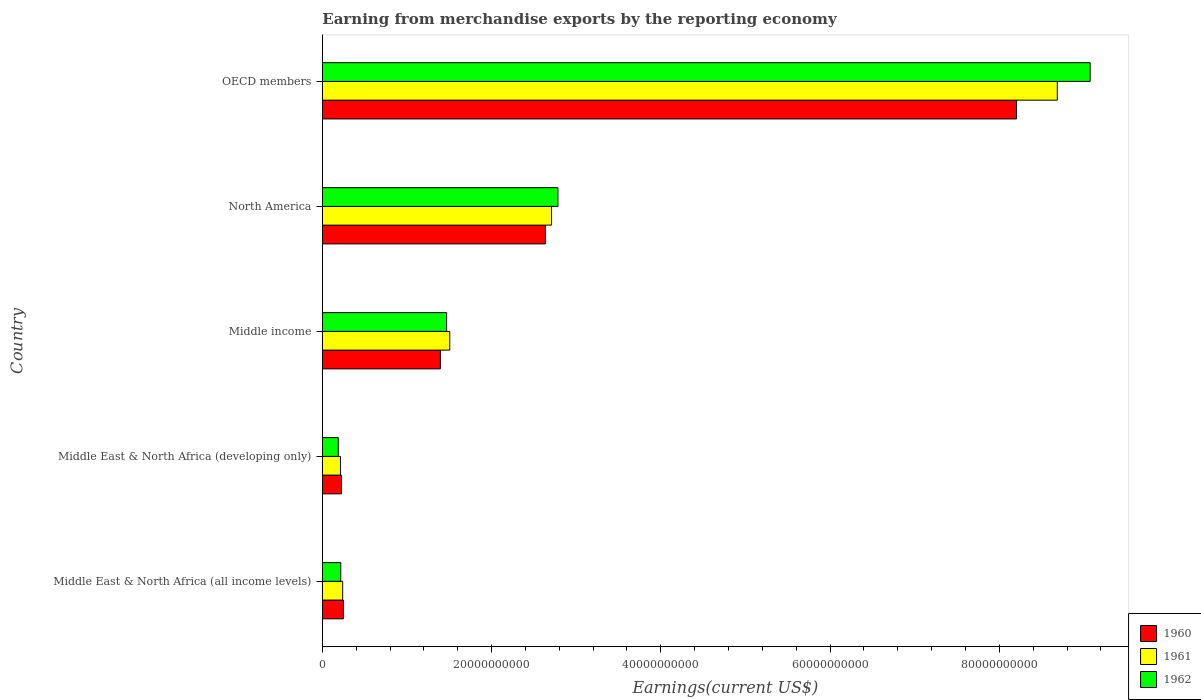Are the number of bars per tick equal to the number of legend labels?
Your response must be concise. Yes. Are the number of bars on each tick of the Y-axis equal?
Your answer should be compact. Yes. How many bars are there on the 4th tick from the bottom?
Ensure brevity in your answer.  3. What is the label of the 2nd group of bars from the top?
Provide a succinct answer. North America. What is the amount earned from merchandise exports in 1960 in OECD members?
Offer a terse response. 8.20e+1. Across all countries, what is the maximum amount earned from merchandise exports in 1960?
Ensure brevity in your answer.  8.20e+1. Across all countries, what is the minimum amount earned from merchandise exports in 1961?
Your answer should be compact. 2.15e+09. In which country was the amount earned from merchandise exports in 1960 maximum?
Make the answer very short. OECD members. In which country was the amount earned from merchandise exports in 1961 minimum?
Give a very brief answer. Middle East & North Africa (developing only). What is the total amount earned from merchandise exports in 1961 in the graph?
Your answer should be compact. 1.34e+11. What is the difference between the amount earned from merchandise exports in 1961 in North America and that in OECD members?
Give a very brief answer. -5.98e+1. What is the difference between the amount earned from merchandise exports in 1962 in Middle East & North Africa (developing only) and the amount earned from merchandise exports in 1960 in OECD members?
Your answer should be very brief. -8.01e+1. What is the average amount earned from merchandise exports in 1961 per country?
Your answer should be very brief. 2.67e+1. What is the difference between the amount earned from merchandise exports in 1960 and amount earned from merchandise exports in 1961 in Middle East & North Africa (developing only)?
Your answer should be compact. 1.18e+08. What is the ratio of the amount earned from merchandise exports in 1962 in Middle East & North Africa (developing only) to that in Middle income?
Keep it short and to the point. 0.13. What is the difference between the highest and the second highest amount earned from merchandise exports in 1960?
Give a very brief answer. 5.57e+1. What is the difference between the highest and the lowest amount earned from merchandise exports in 1961?
Give a very brief answer. 8.47e+1. In how many countries, is the amount earned from merchandise exports in 1960 greater than the average amount earned from merchandise exports in 1960 taken over all countries?
Provide a succinct answer. 2. Is the sum of the amount earned from merchandise exports in 1961 in Middle income and OECD members greater than the maximum amount earned from merchandise exports in 1962 across all countries?
Your response must be concise. Yes. What does the 1st bar from the top in North America represents?
Offer a terse response. 1962. What does the 2nd bar from the bottom in North America represents?
Offer a very short reply. 1961. Is it the case that in every country, the sum of the amount earned from merchandise exports in 1961 and amount earned from merchandise exports in 1962 is greater than the amount earned from merchandise exports in 1960?
Give a very brief answer. Yes. How many bars are there?
Give a very brief answer. 15. Are all the bars in the graph horizontal?
Offer a very short reply. Yes. How many countries are there in the graph?
Your response must be concise. 5. Does the graph contain any zero values?
Offer a very short reply. No. How many legend labels are there?
Offer a terse response. 3. How are the legend labels stacked?
Provide a short and direct response. Vertical. What is the title of the graph?
Provide a short and direct response. Earning from merchandise exports by the reporting economy. Does "1984" appear as one of the legend labels in the graph?
Your answer should be very brief. No. What is the label or title of the X-axis?
Make the answer very short. Earnings(current US$). What is the label or title of the Y-axis?
Make the answer very short. Country. What is the Earnings(current US$) of 1960 in Middle East & North Africa (all income levels)?
Your answer should be compact. 2.49e+09. What is the Earnings(current US$) in 1961 in Middle East & North Africa (all income levels)?
Keep it short and to the point. 2.40e+09. What is the Earnings(current US$) of 1962 in Middle East & North Africa (all income levels)?
Keep it short and to the point. 2.18e+09. What is the Earnings(current US$) of 1960 in Middle East & North Africa (developing only)?
Offer a terse response. 2.26e+09. What is the Earnings(current US$) in 1961 in Middle East & North Africa (developing only)?
Your answer should be compact. 2.15e+09. What is the Earnings(current US$) of 1962 in Middle East & North Africa (developing only)?
Make the answer very short. 1.89e+09. What is the Earnings(current US$) in 1960 in Middle income?
Ensure brevity in your answer.  1.39e+1. What is the Earnings(current US$) of 1961 in Middle income?
Your response must be concise. 1.51e+1. What is the Earnings(current US$) of 1962 in Middle income?
Your answer should be very brief. 1.47e+1. What is the Earnings(current US$) in 1960 in North America?
Provide a short and direct response. 2.64e+1. What is the Earnings(current US$) of 1961 in North America?
Ensure brevity in your answer.  2.71e+1. What is the Earnings(current US$) of 1962 in North America?
Offer a terse response. 2.78e+1. What is the Earnings(current US$) in 1960 in OECD members?
Make the answer very short. 8.20e+1. What is the Earnings(current US$) of 1961 in OECD members?
Make the answer very short. 8.68e+1. What is the Earnings(current US$) in 1962 in OECD members?
Make the answer very short. 9.07e+1. Across all countries, what is the maximum Earnings(current US$) of 1960?
Provide a short and direct response. 8.20e+1. Across all countries, what is the maximum Earnings(current US$) in 1961?
Your response must be concise. 8.68e+1. Across all countries, what is the maximum Earnings(current US$) in 1962?
Your answer should be very brief. 9.07e+1. Across all countries, what is the minimum Earnings(current US$) in 1960?
Your response must be concise. 2.26e+09. Across all countries, what is the minimum Earnings(current US$) of 1961?
Give a very brief answer. 2.15e+09. Across all countries, what is the minimum Earnings(current US$) in 1962?
Offer a terse response. 1.89e+09. What is the total Earnings(current US$) in 1960 in the graph?
Your response must be concise. 1.27e+11. What is the total Earnings(current US$) of 1961 in the graph?
Provide a succinct answer. 1.34e+11. What is the total Earnings(current US$) in 1962 in the graph?
Offer a very short reply. 1.37e+11. What is the difference between the Earnings(current US$) in 1960 in Middle East & North Africa (all income levels) and that in Middle East & North Africa (developing only)?
Make the answer very short. 2.25e+08. What is the difference between the Earnings(current US$) of 1961 in Middle East & North Africa (all income levels) and that in Middle East & North Africa (developing only)?
Your answer should be very brief. 2.58e+08. What is the difference between the Earnings(current US$) in 1962 in Middle East & North Africa (all income levels) and that in Middle East & North Africa (developing only)?
Make the answer very short. 2.90e+08. What is the difference between the Earnings(current US$) in 1960 in Middle East & North Africa (all income levels) and that in Middle income?
Make the answer very short. -1.15e+1. What is the difference between the Earnings(current US$) in 1961 in Middle East & North Africa (all income levels) and that in Middle income?
Offer a very short reply. -1.27e+1. What is the difference between the Earnings(current US$) of 1962 in Middle East & North Africa (all income levels) and that in Middle income?
Keep it short and to the point. -1.25e+1. What is the difference between the Earnings(current US$) of 1960 in Middle East & North Africa (all income levels) and that in North America?
Provide a short and direct response. -2.39e+1. What is the difference between the Earnings(current US$) of 1961 in Middle East & North Africa (all income levels) and that in North America?
Offer a terse response. -2.47e+1. What is the difference between the Earnings(current US$) of 1962 in Middle East & North Africa (all income levels) and that in North America?
Offer a terse response. -2.57e+1. What is the difference between the Earnings(current US$) of 1960 in Middle East & North Africa (all income levels) and that in OECD members?
Ensure brevity in your answer.  -7.95e+1. What is the difference between the Earnings(current US$) of 1961 in Middle East & North Africa (all income levels) and that in OECD members?
Ensure brevity in your answer.  -8.44e+1. What is the difference between the Earnings(current US$) of 1962 in Middle East & North Africa (all income levels) and that in OECD members?
Give a very brief answer. -8.86e+1. What is the difference between the Earnings(current US$) of 1960 in Middle East & North Africa (developing only) and that in Middle income?
Provide a short and direct response. -1.17e+1. What is the difference between the Earnings(current US$) in 1961 in Middle East & North Africa (developing only) and that in Middle income?
Make the answer very short. -1.29e+1. What is the difference between the Earnings(current US$) of 1962 in Middle East & North Africa (developing only) and that in Middle income?
Your response must be concise. -1.28e+1. What is the difference between the Earnings(current US$) of 1960 in Middle East & North Africa (developing only) and that in North America?
Your answer should be compact. -2.41e+1. What is the difference between the Earnings(current US$) of 1961 in Middle East & North Africa (developing only) and that in North America?
Provide a succinct answer. -2.49e+1. What is the difference between the Earnings(current US$) in 1962 in Middle East & North Africa (developing only) and that in North America?
Make the answer very short. -2.60e+1. What is the difference between the Earnings(current US$) in 1960 in Middle East & North Africa (developing only) and that in OECD members?
Offer a terse response. -7.98e+1. What is the difference between the Earnings(current US$) of 1961 in Middle East & North Africa (developing only) and that in OECD members?
Offer a terse response. -8.47e+1. What is the difference between the Earnings(current US$) of 1962 in Middle East & North Africa (developing only) and that in OECD members?
Keep it short and to the point. -8.88e+1. What is the difference between the Earnings(current US$) in 1960 in Middle income and that in North America?
Offer a very short reply. -1.24e+1. What is the difference between the Earnings(current US$) in 1961 in Middle income and that in North America?
Your answer should be very brief. -1.20e+1. What is the difference between the Earnings(current US$) of 1962 in Middle income and that in North America?
Your response must be concise. -1.32e+1. What is the difference between the Earnings(current US$) in 1960 in Middle income and that in OECD members?
Your response must be concise. -6.81e+1. What is the difference between the Earnings(current US$) in 1961 in Middle income and that in OECD members?
Offer a terse response. -7.18e+1. What is the difference between the Earnings(current US$) of 1962 in Middle income and that in OECD members?
Make the answer very short. -7.60e+1. What is the difference between the Earnings(current US$) of 1960 in North America and that in OECD members?
Ensure brevity in your answer.  -5.57e+1. What is the difference between the Earnings(current US$) of 1961 in North America and that in OECD members?
Your answer should be very brief. -5.98e+1. What is the difference between the Earnings(current US$) in 1962 in North America and that in OECD members?
Your answer should be compact. -6.29e+1. What is the difference between the Earnings(current US$) of 1960 in Middle East & North Africa (all income levels) and the Earnings(current US$) of 1961 in Middle East & North Africa (developing only)?
Your answer should be compact. 3.43e+08. What is the difference between the Earnings(current US$) of 1960 in Middle East & North Africa (all income levels) and the Earnings(current US$) of 1962 in Middle East & North Africa (developing only)?
Give a very brief answer. 6.02e+08. What is the difference between the Earnings(current US$) of 1961 in Middle East & North Africa (all income levels) and the Earnings(current US$) of 1962 in Middle East & North Africa (developing only)?
Your answer should be compact. 5.17e+08. What is the difference between the Earnings(current US$) of 1960 in Middle East & North Africa (all income levels) and the Earnings(current US$) of 1961 in Middle income?
Make the answer very short. -1.26e+1. What is the difference between the Earnings(current US$) of 1960 in Middle East & North Africa (all income levels) and the Earnings(current US$) of 1962 in Middle income?
Provide a short and direct response. -1.22e+1. What is the difference between the Earnings(current US$) in 1961 in Middle East & North Africa (all income levels) and the Earnings(current US$) in 1962 in Middle income?
Provide a succinct answer. -1.23e+1. What is the difference between the Earnings(current US$) of 1960 in Middle East & North Africa (all income levels) and the Earnings(current US$) of 1961 in North America?
Provide a short and direct response. -2.46e+1. What is the difference between the Earnings(current US$) of 1960 in Middle East & North Africa (all income levels) and the Earnings(current US$) of 1962 in North America?
Your answer should be compact. -2.54e+1. What is the difference between the Earnings(current US$) of 1961 in Middle East & North Africa (all income levels) and the Earnings(current US$) of 1962 in North America?
Provide a succinct answer. -2.54e+1. What is the difference between the Earnings(current US$) of 1960 in Middle East & North Africa (all income levels) and the Earnings(current US$) of 1961 in OECD members?
Keep it short and to the point. -8.44e+1. What is the difference between the Earnings(current US$) of 1960 in Middle East & North Africa (all income levels) and the Earnings(current US$) of 1962 in OECD members?
Keep it short and to the point. -8.82e+1. What is the difference between the Earnings(current US$) in 1961 in Middle East & North Africa (all income levels) and the Earnings(current US$) in 1962 in OECD members?
Offer a terse response. -8.83e+1. What is the difference between the Earnings(current US$) in 1960 in Middle East & North Africa (developing only) and the Earnings(current US$) in 1961 in Middle income?
Your response must be concise. -1.28e+1. What is the difference between the Earnings(current US$) of 1960 in Middle East & North Africa (developing only) and the Earnings(current US$) of 1962 in Middle income?
Ensure brevity in your answer.  -1.24e+1. What is the difference between the Earnings(current US$) of 1961 in Middle East & North Africa (developing only) and the Earnings(current US$) of 1962 in Middle income?
Your answer should be compact. -1.25e+1. What is the difference between the Earnings(current US$) of 1960 in Middle East & North Africa (developing only) and the Earnings(current US$) of 1961 in North America?
Offer a very short reply. -2.48e+1. What is the difference between the Earnings(current US$) of 1960 in Middle East & North Africa (developing only) and the Earnings(current US$) of 1962 in North America?
Your response must be concise. -2.56e+1. What is the difference between the Earnings(current US$) of 1961 in Middle East & North Africa (developing only) and the Earnings(current US$) of 1962 in North America?
Offer a terse response. -2.57e+1. What is the difference between the Earnings(current US$) of 1960 in Middle East & North Africa (developing only) and the Earnings(current US$) of 1961 in OECD members?
Offer a terse response. -8.46e+1. What is the difference between the Earnings(current US$) in 1960 in Middle East & North Africa (developing only) and the Earnings(current US$) in 1962 in OECD members?
Offer a terse response. -8.85e+1. What is the difference between the Earnings(current US$) of 1961 in Middle East & North Africa (developing only) and the Earnings(current US$) of 1962 in OECD members?
Offer a terse response. -8.86e+1. What is the difference between the Earnings(current US$) of 1960 in Middle income and the Earnings(current US$) of 1961 in North America?
Your answer should be compact. -1.31e+1. What is the difference between the Earnings(current US$) in 1960 in Middle income and the Earnings(current US$) in 1962 in North America?
Make the answer very short. -1.39e+1. What is the difference between the Earnings(current US$) of 1961 in Middle income and the Earnings(current US$) of 1962 in North America?
Your answer should be very brief. -1.28e+1. What is the difference between the Earnings(current US$) of 1960 in Middle income and the Earnings(current US$) of 1961 in OECD members?
Give a very brief answer. -7.29e+1. What is the difference between the Earnings(current US$) of 1960 in Middle income and the Earnings(current US$) of 1962 in OECD members?
Make the answer very short. -7.68e+1. What is the difference between the Earnings(current US$) of 1961 in Middle income and the Earnings(current US$) of 1962 in OECD members?
Provide a short and direct response. -7.57e+1. What is the difference between the Earnings(current US$) of 1960 in North America and the Earnings(current US$) of 1961 in OECD members?
Your answer should be compact. -6.05e+1. What is the difference between the Earnings(current US$) in 1960 in North America and the Earnings(current US$) in 1962 in OECD members?
Your answer should be very brief. -6.44e+1. What is the difference between the Earnings(current US$) in 1961 in North America and the Earnings(current US$) in 1962 in OECD members?
Provide a succinct answer. -6.36e+1. What is the average Earnings(current US$) of 1960 per country?
Your response must be concise. 2.54e+1. What is the average Earnings(current US$) of 1961 per country?
Make the answer very short. 2.67e+1. What is the average Earnings(current US$) in 1962 per country?
Provide a succinct answer. 2.75e+1. What is the difference between the Earnings(current US$) in 1960 and Earnings(current US$) in 1961 in Middle East & North Africa (all income levels)?
Keep it short and to the point. 8.50e+07. What is the difference between the Earnings(current US$) of 1960 and Earnings(current US$) of 1962 in Middle East & North Africa (all income levels)?
Your answer should be compact. 3.12e+08. What is the difference between the Earnings(current US$) in 1961 and Earnings(current US$) in 1962 in Middle East & North Africa (all income levels)?
Provide a short and direct response. 2.27e+08. What is the difference between the Earnings(current US$) in 1960 and Earnings(current US$) in 1961 in Middle East & North Africa (developing only)?
Provide a succinct answer. 1.18e+08. What is the difference between the Earnings(current US$) in 1960 and Earnings(current US$) in 1962 in Middle East & North Africa (developing only)?
Your response must be concise. 3.77e+08. What is the difference between the Earnings(current US$) of 1961 and Earnings(current US$) of 1962 in Middle East & North Africa (developing only)?
Make the answer very short. 2.59e+08. What is the difference between the Earnings(current US$) of 1960 and Earnings(current US$) of 1961 in Middle income?
Your answer should be very brief. -1.11e+09. What is the difference between the Earnings(current US$) in 1960 and Earnings(current US$) in 1962 in Middle income?
Give a very brief answer. -7.36e+08. What is the difference between the Earnings(current US$) in 1961 and Earnings(current US$) in 1962 in Middle income?
Offer a very short reply. 3.73e+08. What is the difference between the Earnings(current US$) in 1960 and Earnings(current US$) in 1961 in North America?
Offer a very short reply. -7.26e+08. What is the difference between the Earnings(current US$) of 1960 and Earnings(current US$) of 1962 in North America?
Your answer should be very brief. -1.48e+09. What is the difference between the Earnings(current US$) in 1961 and Earnings(current US$) in 1962 in North America?
Give a very brief answer. -7.54e+08. What is the difference between the Earnings(current US$) of 1960 and Earnings(current US$) of 1961 in OECD members?
Your answer should be compact. -4.82e+09. What is the difference between the Earnings(current US$) of 1960 and Earnings(current US$) of 1962 in OECD members?
Make the answer very short. -8.70e+09. What is the difference between the Earnings(current US$) in 1961 and Earnings(current US$) in 1962 in OECD members?
Provide a succinct answer. -3.88e+09. What is the ratio of the Earnings(current US$) of 1960 in Middle East & North Africa (all income levels) to that in Middle East & North Africa (developing only)?
Keep it short and to the point. 1.1. What is the ratio of the Earnings(current US$) in 1961 in Middle East & North Africa (all income levels) to that in Middle East & North Africa (developing only)?
Your response must be concise. 1.12. What is the ratio of the Earnings(current US$) of 1962 in Middle East & North Africa (all income levels) to that in Middle East & North Africa (developing only)?
Your response must be concise. 1.15. What is the ratio of the Earnings(current US$) in 1960 in Middle East & North Africa (all income levels) to that in Middle income?
Your answer should be very brief. 0.18. What is the ratio of the Earnings(current US$) in 1961 in Middle East & North Africa (all income levels) to that in Middle income?
Provide a succinct answer. 0.16. What is the ratio of the Earnings(current US$) in 1962 in Middle East & North Africa (all income levels) to that in Middle income?
Provide a succinct answer. 0.15. What is the ratio of the Earnings(current US$) in 1960 in Middle East & North Africa (all income levels) to that in North America?
Offer a terse response. 0.09. What is the ratio of the Earnings(current US$) of 1961 in Middle East & North Africa (all income levels) to that in North America?
Offer a very short reply. 0.09. What is the ratio of the Earnings(current US$) in 1962 in Middle East & North Africa (all income levels) to that in North America?
Ensure brevity in your answer.  0.08. What is the ratio of the Earnings(current US$) of 1960 in Middle East & North Africa (all income levels) to that in OECD members?
Provide a succinct answer. 0.03. What is the ratio of the Earnings(current US$) of 1961 in Middle East & North Africa (all income levels) to that in OECD members?
Ensure brevity in your answer.  0.03. What is the ratio of the Earnings(current US$) in 1962 in Middle East & North Africa (all income levels) to that in OECD members?
Your response must be concise. 0.02. What is the ratio of the Earnings(current US$) in 1960 in Middle East & North Africa (developing only) to that in Middle income?
Ensure brevity in your answer.  0.16. What is the ratio of the Earnings(current US$) in 1961 in Middle East & North Africa (developing only) to that in Middle income?
Provide a succinct answer. 0.14. What is the ratio of the Earnings(current US$) of 1962 in Middle East & North Africa (developing only) to that in Middle income?
Your answer should be very brief. 0.13. What is the ratio of the Earnings(current US$) in 1960 in Middle East & North Africa (developing only) to that in North America?
Provide a short and direct response. 0.09. What is the ratio of the Earnings(current US$) of 1961 in Middle East & North Africa (developing only) to that in North America?
Provide a succinct answer. 0.08. What is the ratio of the Earnings(current US$) in 1962 in Middle East & North Africa (developing only) to that in North America?
Your response must be concise. 0.07. What is the ratio of the Earnings(current US$) in 1960 in Middle East & North Africa (developing only) to that in OECD members?
Ensure brevity in your answer.  0.03. What is the ratio of the Earnings(current US$) in 1961 in Middle East & North Africa (developing only) to that in OECD members?
Ensure brevity in your answer.  0.02. What is the ratio of the Earnings(current US$) in 1962 in Middle East & North Africa (developing only) to that in OECD members?
Your answer should be compact. 0.02. What is the ratio of the Earnings(current US$) of 1960 in Middle income to that in North America?
Your response must be concise. 0.53. What is the ratio of the Earnings(current US$) of 1961 in Middle income to that in North America?
Give a very brief answer. 0.56. What is the ratio of the Earnings(current US$) of 1962 in Middle income to that in North America?
Keep it short and to the point. 0.53. What is the ratio of the Earnings(current US$) in 1960 in Middle income to that in OECD members?
Offer a terse response. 0.17. What is the ratio of the Earnings(current US$) of 1961 in Middle income to that in OECD members?
Give a very brief answer. 0.17. What is the ratio of the Earnings(current US$) of 1962 in Middle income to that in OECD members?
Ensure brevity in your answer.  0.16. What is the ratio of the Earnings(current US$) of 1960 in North America to that in OECD members?
Provide a succinct answer. 0.32. What is the ratio of the Earnings(current US$) of 1961 in North America to that in OECD members?
Provide a succinct answer. 0.31. What is the ratio of the Earnings(current US$) of 1962 in North America to that in OECD members?
Provide a short and direct response. 0.31. What is the difference between the highest and the second highest Earnings(current US$) in 1960?
Provide a succinct answer. 5.57e+1. What is the difference between the highest and the second highest Earnings(current US$) of 1961?
Ensure brevity in your answer.  5.98e+1. What is the difference between the highest and the second highest Earnings(current US$) of 1962?
Offer a terse response. 6.29e+1. What is the difference between the highest and the lowest Earnings(current US$) of 1960?
Offer a very short reply. 7.98e+1. What is the difference between the highest and the lowest Earnings(current US$) of 1961?
Keep it short and to the point. 8.47e+1. What is the difference between the highest and the lowest Earnings(current US$) of 1962?
Give a very brief answer. 8.88e+1. 